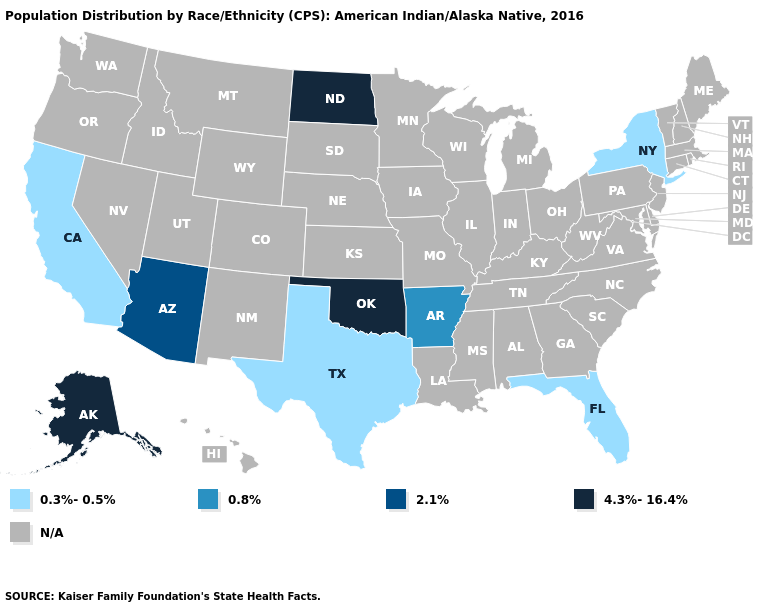Does Arkansas have the lowest value in the USA?
Write a very short answer. No. What is the highest value in the USA?
Answer briefly. 4.3%-16.4%. Which states hav the highest value in the West?
Be succinct. Alaska. Name the states that have a value in the range 0.3%-0.5%?
Answer briefly. California, Florida, New York, Texas. What is the lowest value in the Northeast?
Keep it brief. 0.3%-0.5%. How many symbols are there in the legend?
Be succinct. 5. Does the map have missing data?
Give a very brief answer. Yes. Does the map have missing data?
Quick response, please. Yes. Among the states that border Missouri , which have the lowest value?
Be succinct. Arkansas. What is the value of Nebraska?
Give a very brief answer. N/A. Among the states that border Arizona , which have the highest value?
Short answer required. California. How many symbols are there in the legend?
Answer briefly. 5. 